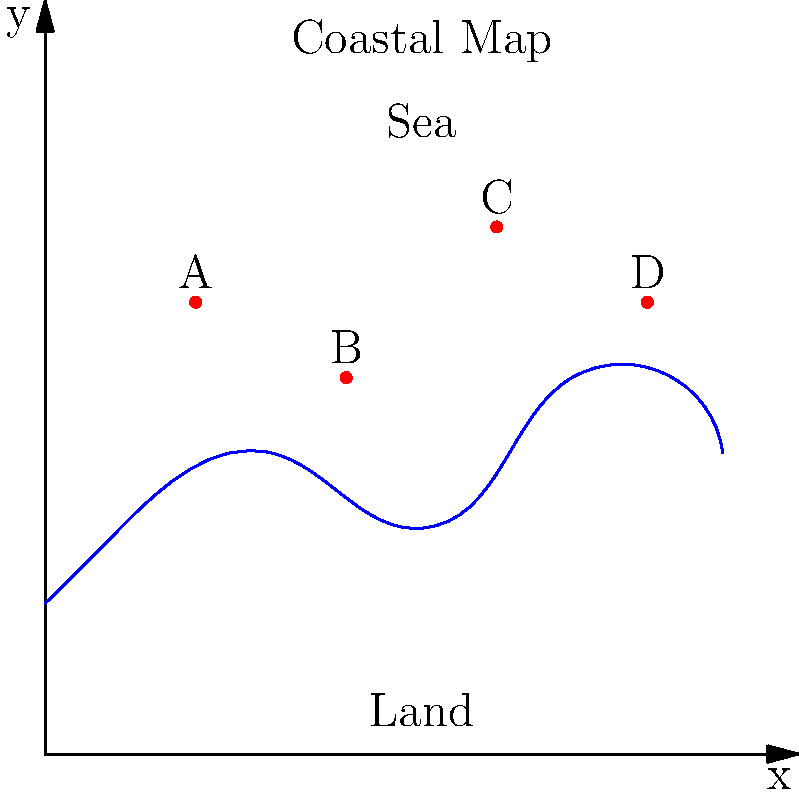Given the coastal map above, where points A(2,6), B(4,5), C(6,7), and D(8,6) represent potential wind farm locations, which site would you recommend for optimal wind energy production? Consider that wind speeds generally increase with distance from the shore, but construction and maintenance costs also rise. Assume a balance is needed between these factors. To determine the optimal location for a wind farm, we need to consider both wind speed potential and construction/maintenance costs. Let's analyze each point:

1. Point A (2,6):
   - Closest to the shore
   - Likely has the lowest wind speed potential
   - Easiest and cheapest to construct and maintain

2. Point B (4,5):
   - Second closest to the shore
   - Moderate wind speed potential
   - Relatively easy to construct and maintain

3. Point C (6,7):
   - Second furthest from the shore
   - Good wind speed potential
   - Moderately difficult to construct and maintain

4. Point D (8,6):
   - Furthest from the shore
   - Highest wind speed potential
   - Most difficult and expensive to construct and maintain

Considering the need for balance between wind speed potential and costs:

- Point A is too close to the shore, likely resulting in suboptimal wind speeds.
- Point D is too far, potentially incurring excessive costs.
- Point B is a good compromise but is slightly closer to the shore than ideal.
- Point C offers a good balance between distance from shore (for higher wind speeds) and proximity (for manageable costs).

Therefore, Point C (6,7) appears to be the optimal choice for wind farm placement.
Answer: Point C (6,7) 